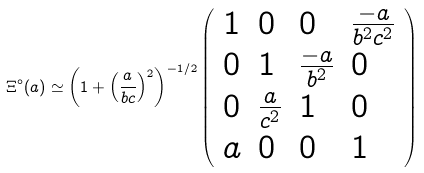<formula> <loc_0><loc_0><loc_500><loc_500>\Xi ^ { \circ } ( a ) \simeq { \left ( 1 + { \left ( \frac { a } { b c } \right ) } ^ { 2 } \right ) } ^ { - 1 / 2 } \left ( \begin{array} { l l l l } 1 & 0 & 0 & \frac { - a } { b ^ { 2 } c ^ { 2 } } \\ 0 & 1 & \frac { - a } { b ^ { 2 } } & 0 \\ 0 & \frac { a } { c ^ { 2 } } & 1 & 0 \\ a & 0 & 0 & 1 \end{array} \right )</formula> 